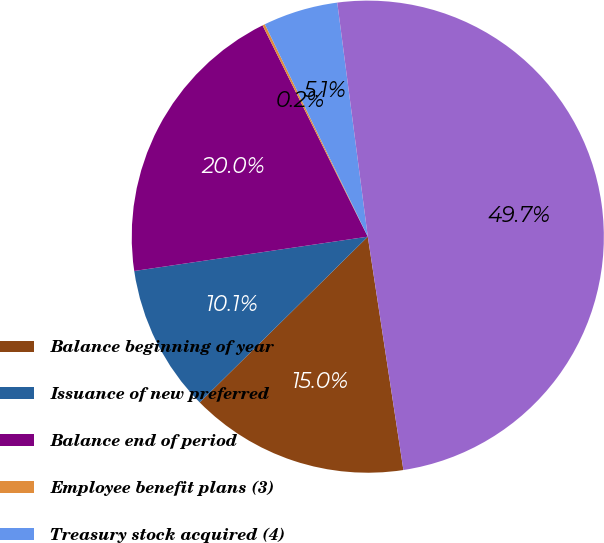<chart> <loc_0><loc_0><loc_500><loc_500><pie_chart><fcel>Balance beginning of year<fcel>Issuance of new preferred<fcel>Balance end of period<fcel>Employee benefit plans (3)<fcel>Treasury stock acquired (4)<fcel>Total Citigroup common<nl><fcel>15.02%<fcel>10.07%<fcel>19.97%<fcel>0.17%<fcel>5.12%<fcel>49.66%<nl></chart> 